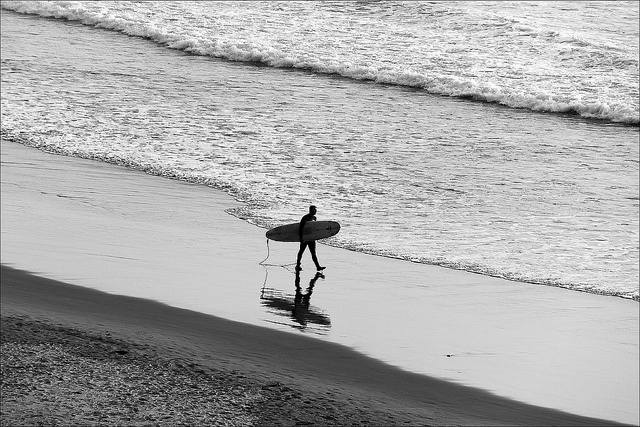Describe the objects in this image and their specific colors. I can see surfboard in black and gray tones and people in black, lightgray, gray, and darkgray tones in this image. 